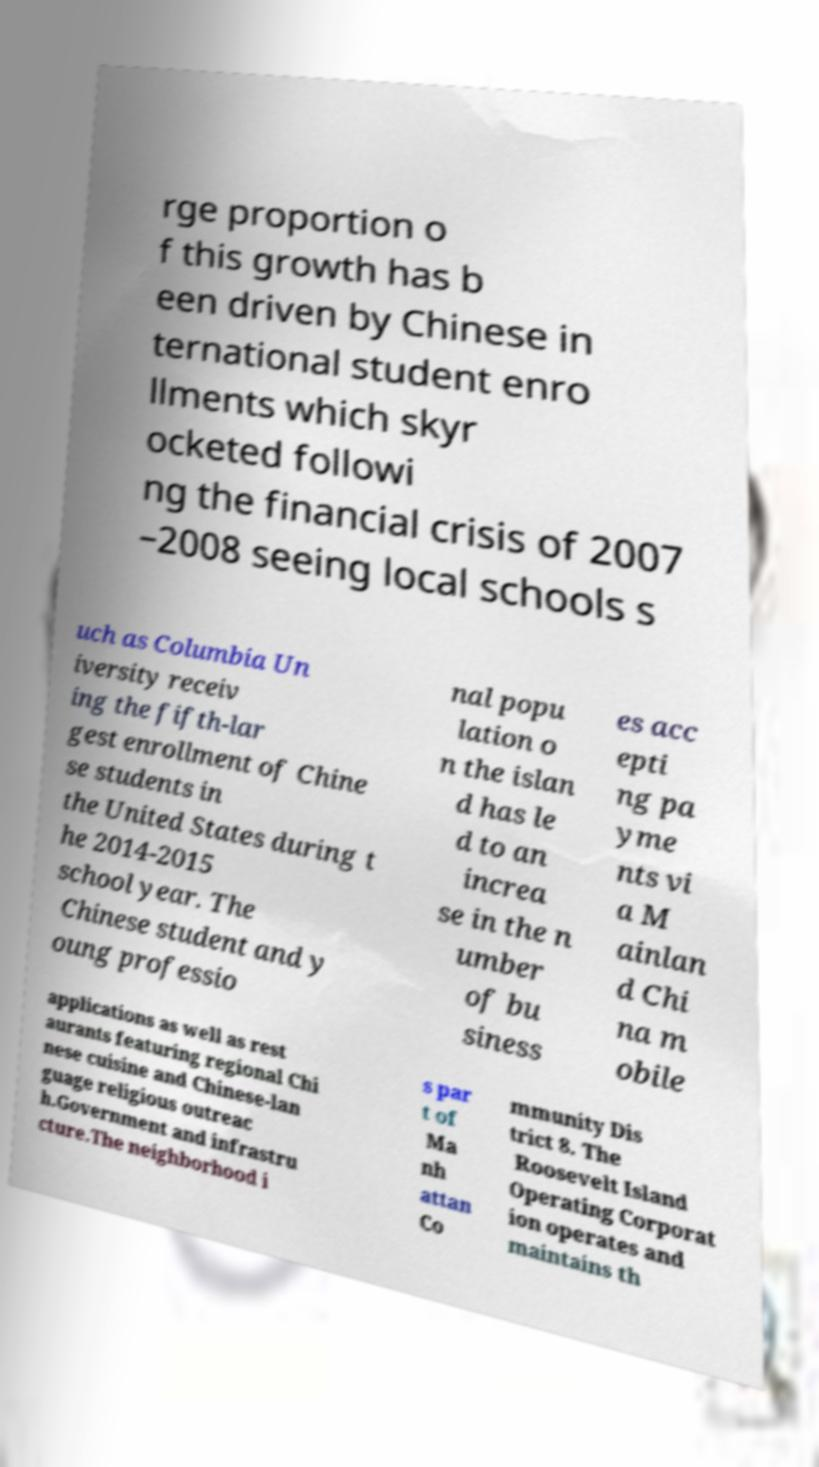There's text embedded in this image that I need extracted. Can you transcribe it verbatim? rge proportion o f this growth has b een driven by Chinese in ternational student enro llments which skyr ocketed followi ng the financial crisis of 2007 –2008 seeing local schools s uch as Columbia Un iversity receiv ing the fifth-lar gest enrollment of Chine se students in the United States during t he 2014-2015 school year. The Chinese student and y oung professio nal popu lation o n the islan d has le d to an increa se in the n umber of bu siness es acc epti ng pa yme nts vi a M ainlan d Chi na m obile applications as well as rest aurants featuring regional Chi nese cuisine and Chinese-lan guage religious outreac h.Government and infrastru cture.The neighborhood i s par t of Ma nh attan Co mmunity Dis trict 8. The Roosevelt Island Operating Corporat ion operates and maintains th 